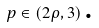<formula> <loc_0><loc_0><loc_500><loc_500>p \in \left ( 2 \rho , 3 \right ) \text {.}</formula> 